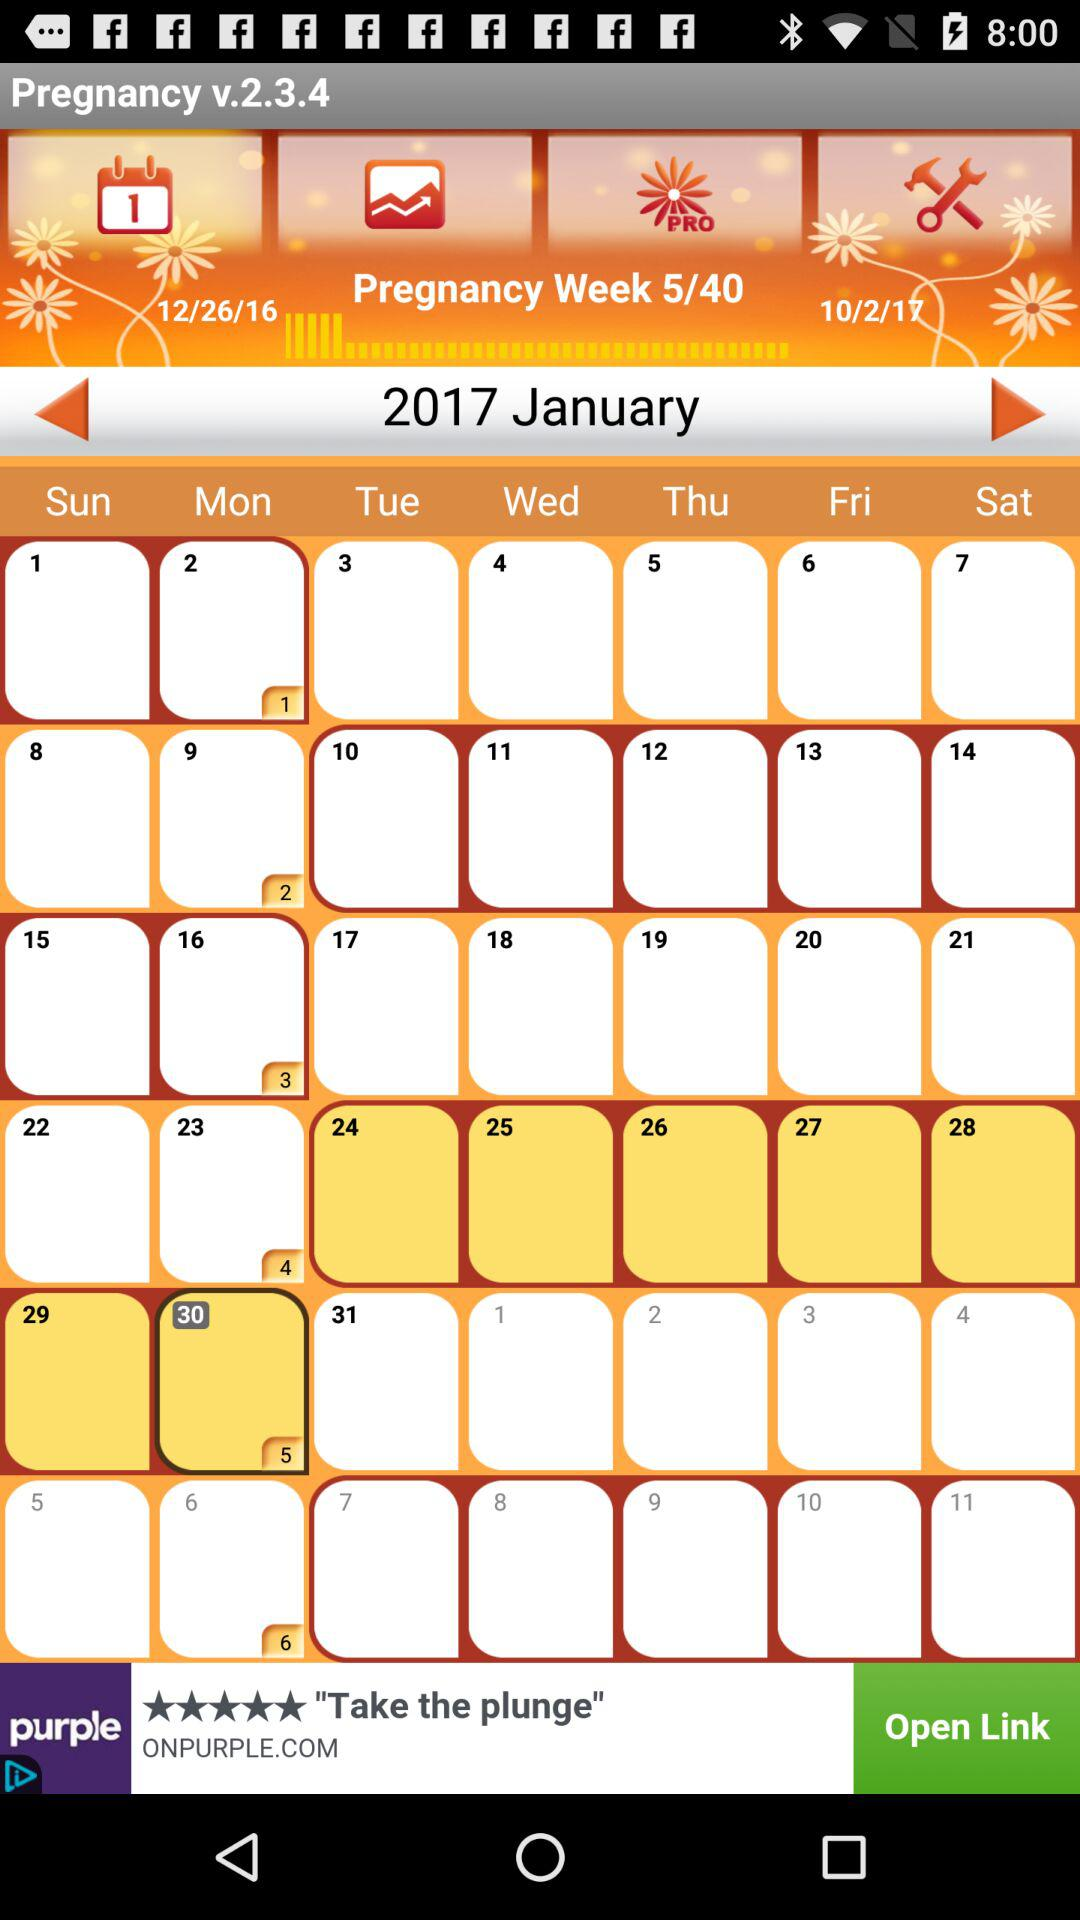Between which dates are the pregnancy weeks held? The pregnancy weeks are held between December 26, 2016 and October 2, 2017. 